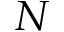Convert formula to latex. <formula><loc_0><loc_0><loc_500><loc_500>N</formula> 